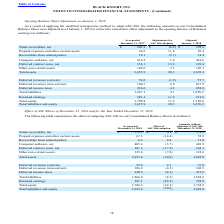According to Black Knight Financial Services's financial document, What were the net trade receivables as reported in 2017? According to the financial document, 201.8 (in millions). The relevant text states: "Trade receivables, net $ 201.8 $ (6.2) $ 195.6..." Also, What were the Receivables from related parties in 2018? According to the financial document, 14.4 (in millions). The relevant text states: "Receivables from related parties 18.1 (3.7) 14.4..." Also, What was the adjustmentments for ASC 606 adoption for net computer software? According to the financial document, 1.8 (in millions). The relevant text states: "Trade receivables, net $ 201.8 $ (6.2) $ 195.6..." Also, can you calculate: What was the difference in amount as reported in 2017 between Total assets and Total liabilities? Based on the calculation: 3,655.9-1,947.1, the result is 1708.8 (in millions). This is based on the information: "Total assets 3,655.9 20.3 3,676.2 Total liabilities 1,947.1 9.1 1,956.2..." The key data points involved are: 1,947.1, 3,655.9. Also, can you calculate: What was the difference between current and non-current deferred revenues after adjustment in 2018? Based on the calculation: 100.7-59.6, the result is 41.1 (in millions). This is based on the information: "Deferred revenues (non-current) 100.7 6.8 107.5 Deferred revenues (current) 59.6 (1.9) 57.7..." The key data points involved are: 100.7, 59.6. Also, can you calculate: What was the difference between Total liabilities and equity and Total Equity as reported in 2017? Based on the calculation: 3,655.9-1,708.8, the result is 1947.1 (in millions). This is based on the information: "Total assets 3,655.9 20.3 3,676.2 Total equity 1,708.8 11.2 1,720.0..." The key data points involved are: 1,708.8, 3,655.9. 